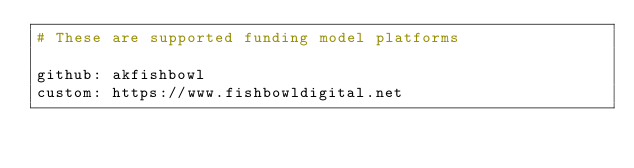<code> <loc_0><loc_0><loc_500><loc_500><_YAML_># These are supported funding model platforms

github: akfishbowl
custom: https://www.fishbowldigital.net
</code> 